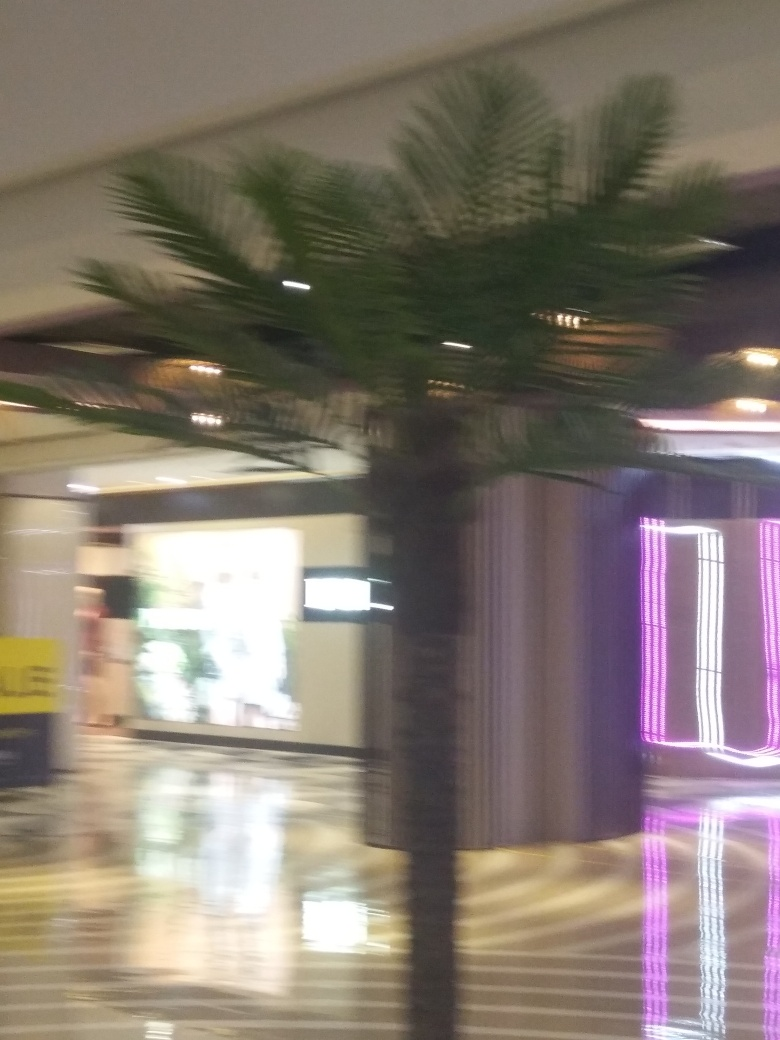Is the image of poor quality? Yes, the image is of poor quality. The blurriness and lack of clear detail suggest that the photo may have been taken in a hurried manner or with an unsteady hand. The subject matter, which appears to be an indoor space featuring a palm tree and some neon lighting, lacks sharpness and clarity, causing the scene to lose its visual impact. 